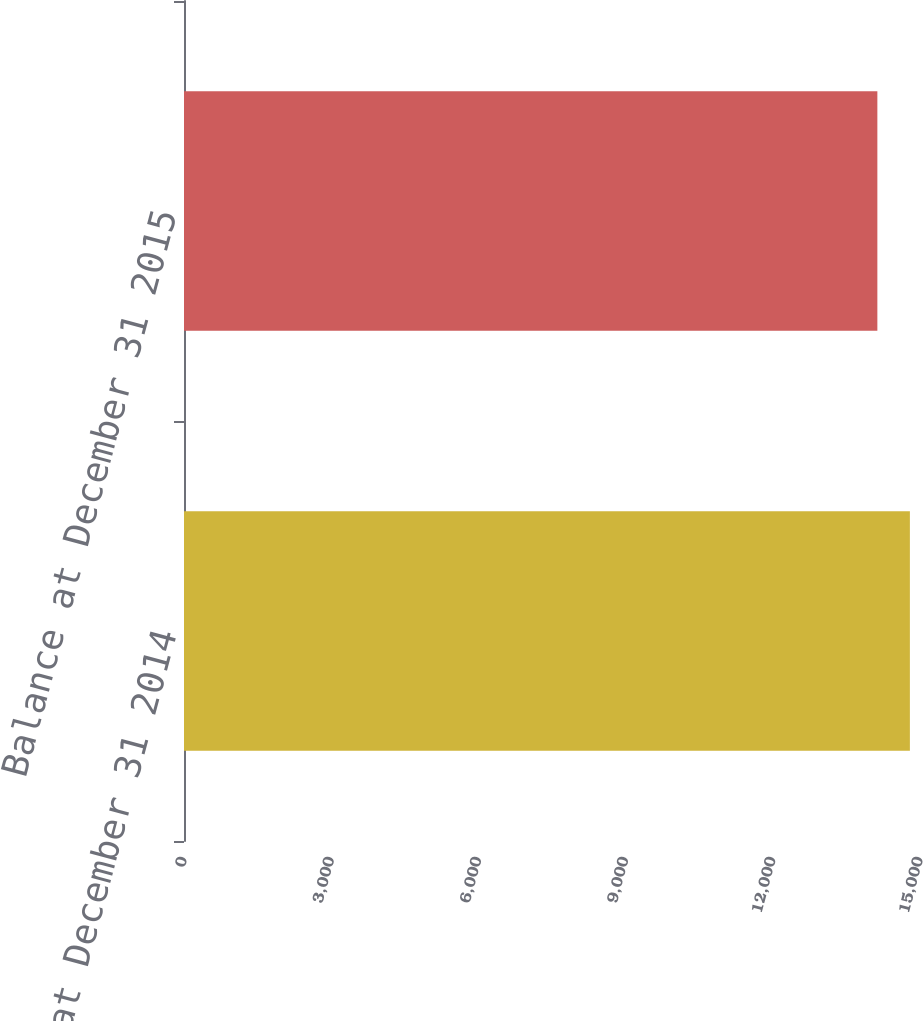Convert chart to OTSL. <chart><loc_0><loc_0><loc_500><loc_500><bar_chart><fcel>Balance at December 31 2014<fcel>Balance at December 31 2015<nl><fcel>14794<fcel>14131<nl></chart> 